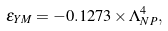<formula> <loc_0><loc_0><loc_500><loc_500>\epsilon _ { Y M } = - 0 . 1 2 7 3 \times \Lambda ^ { 4 } _ { N P } ,</formula> 